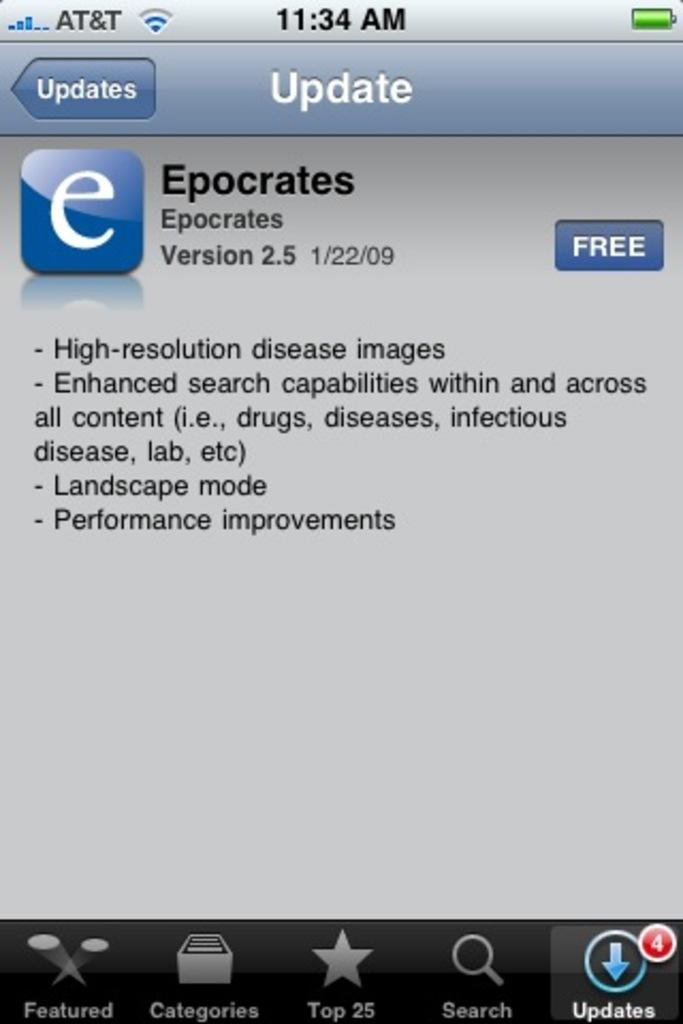<image>
Create a compact narrative representing the image presented. AT&T is written over the word Updates on a screen. 